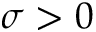Convert formula to latex. <formula><loc_0><loc_0><loc_500><loc_500>\sigma > 0</formula> 